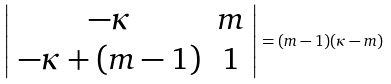Convert formula to latex. <formula><loc_0><loc_0><loc_500><loc_500>\left | \begin{array} { c c } - \kappa & m \\ - \kappa + ( m - 1 ) & 1 \end{array} \right | = ( m - 1 ) ( \kappa - m )</formula> 